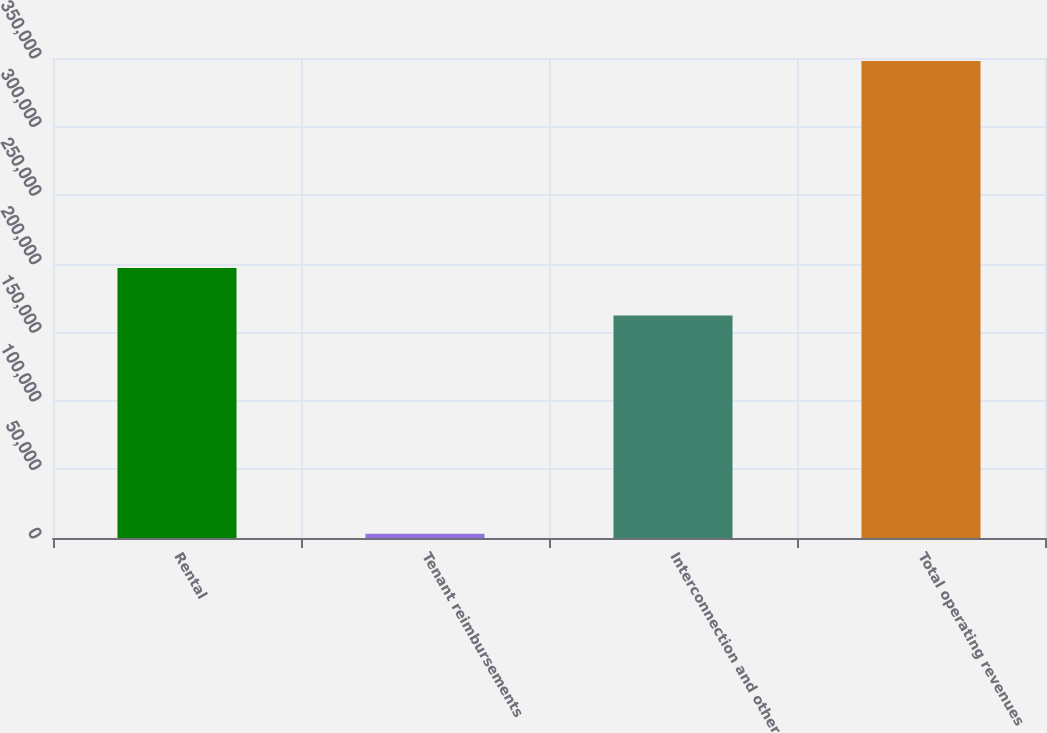<chart> <loc_0><loc_0><loc_500><loc_500><bar_chart><fcel>Rental<fcel>Tenant reimbursements<fcel>Interconnection and other<fcel>Total operating revenues<nl><fcel>196788<fcel>3010<fcel>162306<fcel>347835<nl></chart> 